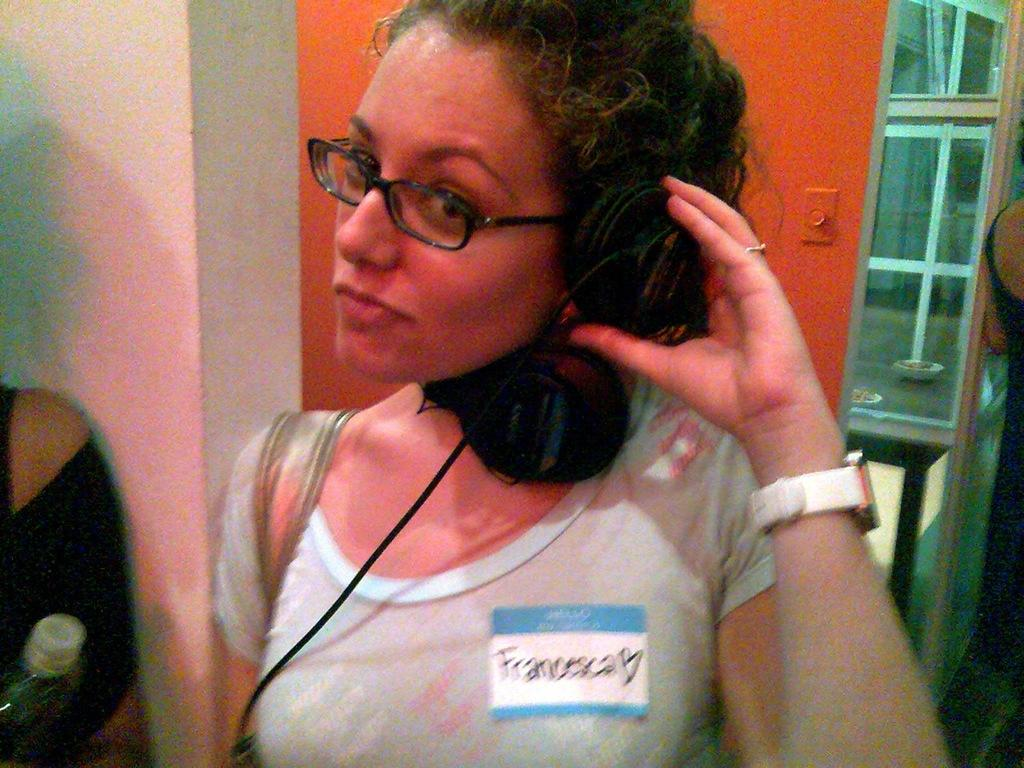Who is present in the image? There is a woman in the image. What is the woman doing in the image? The woman is standing in the image. What is the woman wearing in the image? The woman is wearing a bag in the image. Can you see a goose in the image? No, there is no goose present in the image. What trick is the woman performing in the image? There is no trick being performed in the image; the woman is simply standing. 